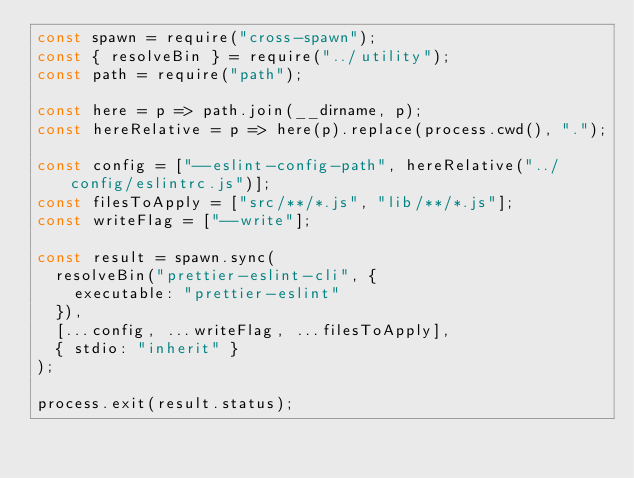Convert code to text. <code><loc_0><loc_0><loc_500><loc_500><_JavaScript_>const spawn = require("cross-spawn");
const { resolveBin } = require("../utility");
const path = require("path");

const here = p => path.join(__dirname, p);
const hereRelative = p => here(p).replace(process.cwd(), ".");

const config = ["--eslint-config-path", hereRelative("../config/eslintrc.js")];
const filesToApply = ["src/**/*.js", "lib/**/*.js"];
const writeFlag = ["--write"];

const result = spawn.sync(
  resolveBin("prettier-eslint-cli", {
    executable: "prettier-eslint"
  }),
  [...config, ...writeFlag, ...filesToApply],
  { stdio: "inherit" }
);

process.exit(result.status);
</code> 